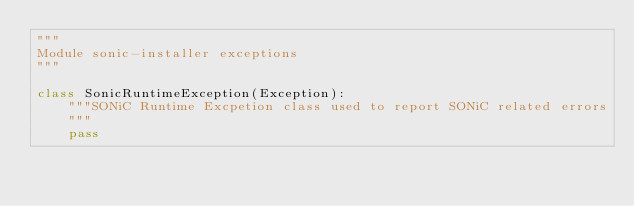<code> <loc_0><loc_0><loc_500><loc_500><_Python_>"""
Module sonic-installer exceptions
"""

class SonicRuntimeException(Exception):
    """SONiC Runtime Excpetion class used to report SONiC related errors
    """
    pass
</code> 